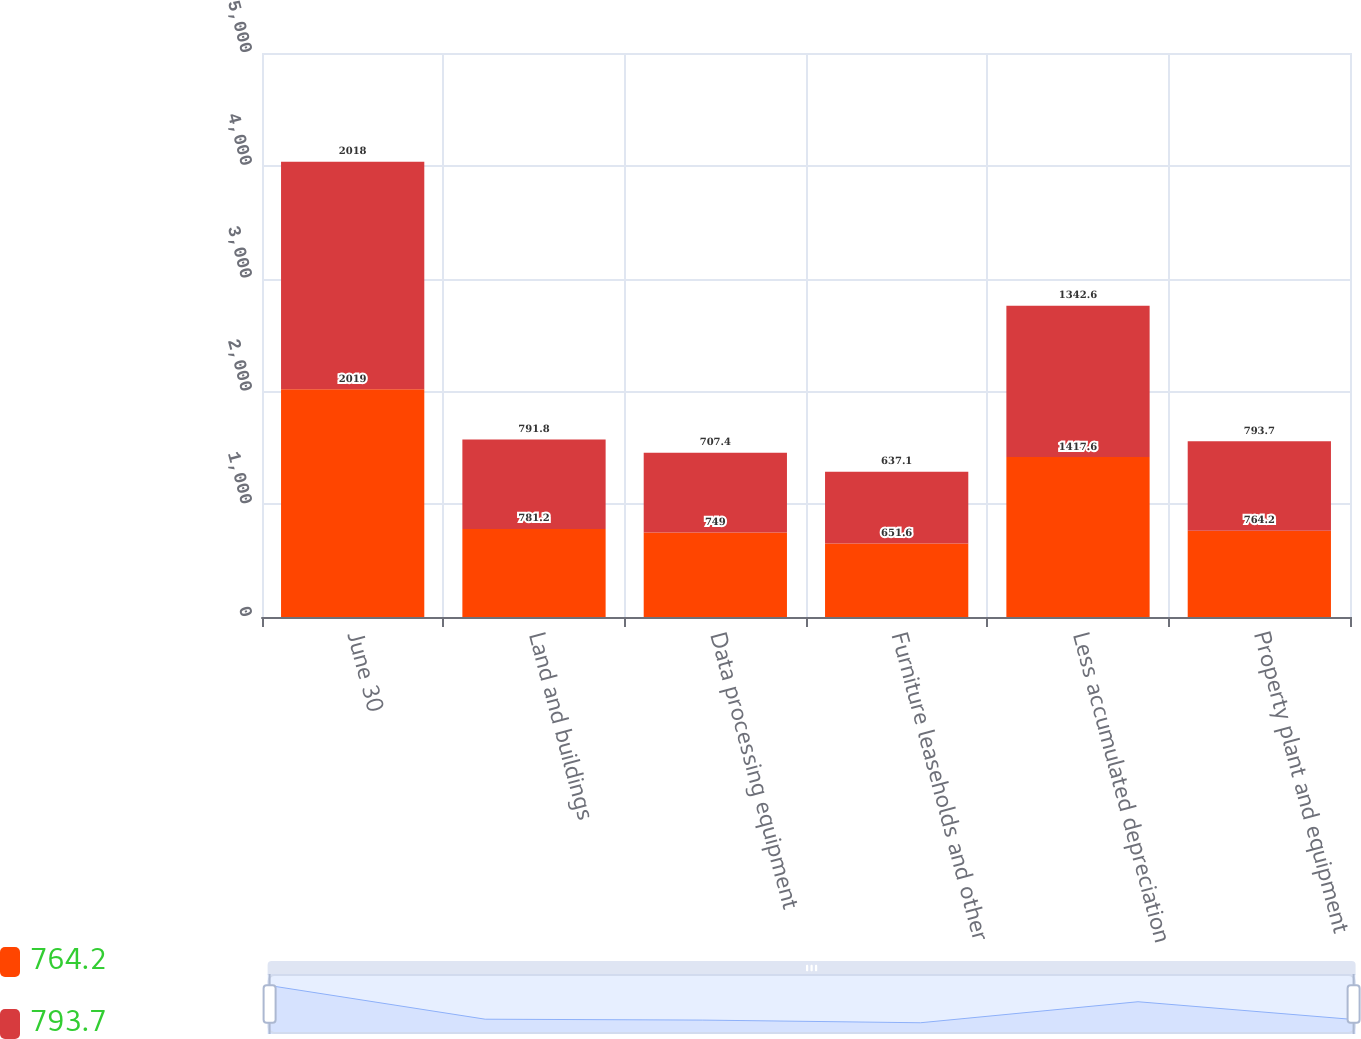<chart> <loc_0><loc_0><loc_500><loc_500><stacked_bar_chart><ecel><fcel>June 30<fcel>Land and buildings<fcel>Data processing equipment<fcel>Furniture leaseholds and other<fcel>Less accumulated depreciation<fcel>Property plant and equipment<nl><fcel>764.2<fcel>2019<fcel>781.2<fcel>749<fcel>651.6<fcel>1417.6<fcel>764.2<nl><fcel>793.7<fcel>2018<fcel>791.8<fcel>707.4<fcel>637.1<fcel>1342.6<fcel>793.7<nl></chart> 